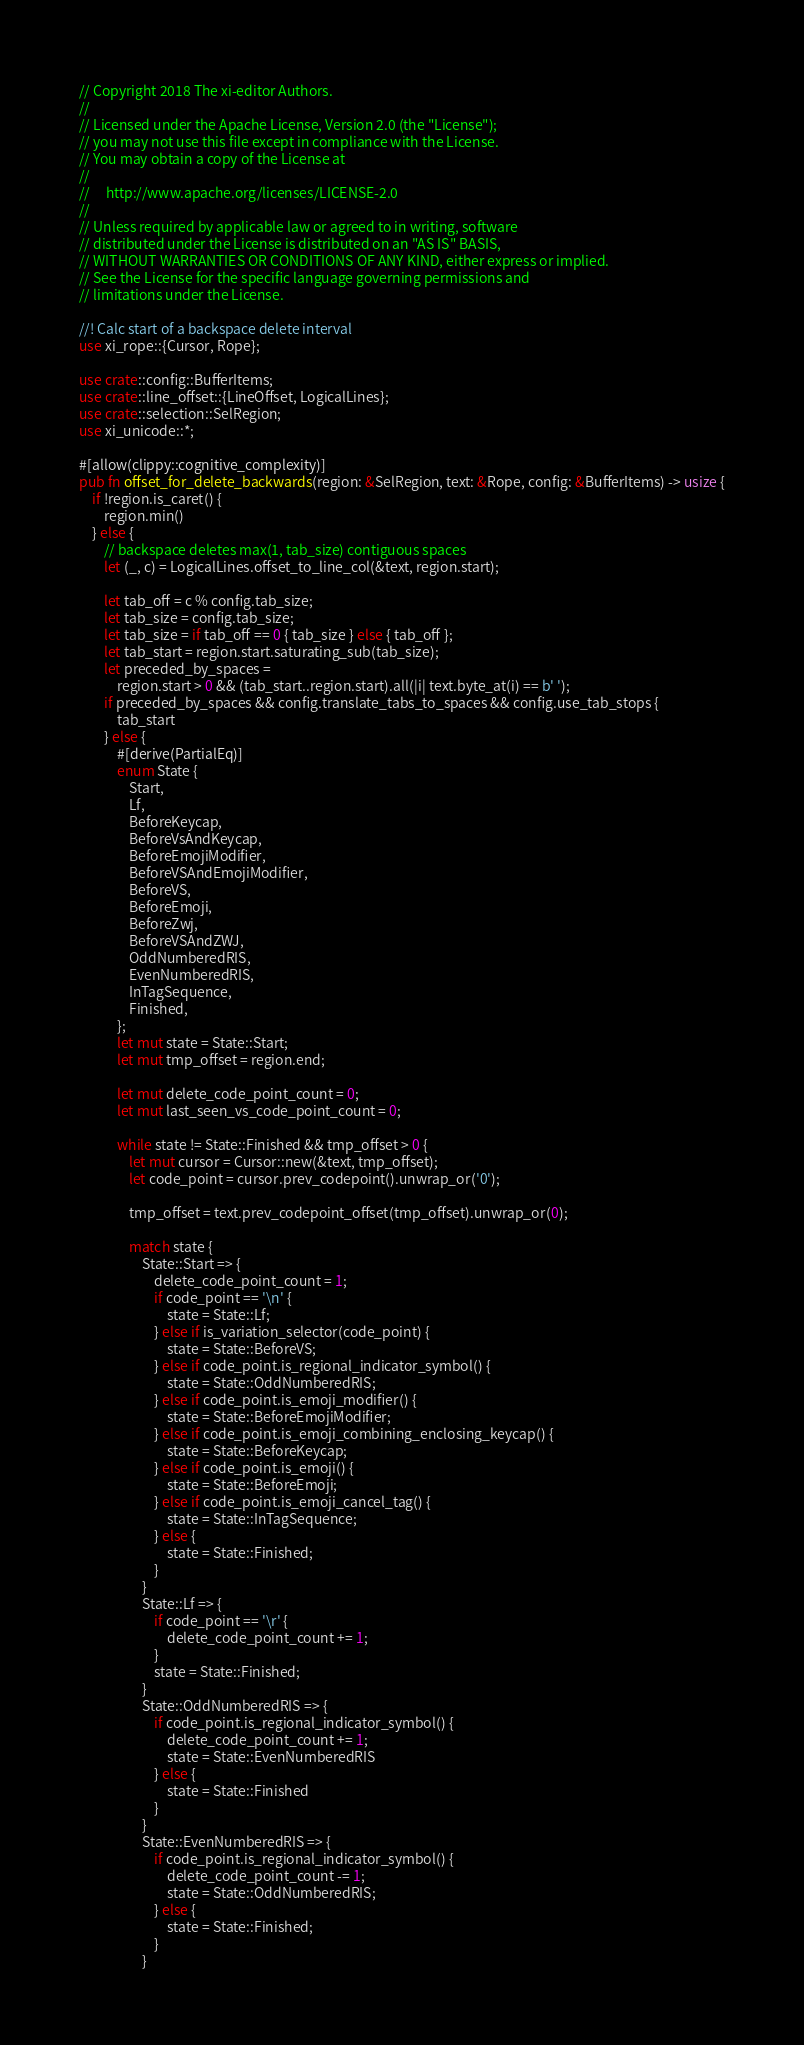<code> <loc_0><loc_0><loc_500><loc_500><_Rust_>// Copyright 2018 The xi-editor Authors.
//
// Licensed under the Apache License, Version 2.0 (the "License");
// you may not use this file except in compliance with the License.
// You may obtain a copy of the License at
//
//     http://www.apache.org/licenses/LICENSE-2.0
//
// Unless required by applicable law or agreed to in writing, software
// distributed under the License is distributed on an "AS IS" BASIS,
// WITHOUT WARRANTIES OR CONDITIONS OF ANY KIND, either express or implied.
// See the License for the specific language governing permissions and
// limitations under the License.

//! Calc start of a backspace delete interval
use xi_rope::{Cursor, Rope};

use crate::config::BufferItems;
use crate::line_offset::{LineOffset, LogicalLines};
use crate::selection::SelRegion;
use xi_unicode::*;

#[allow(clippy::cognitive_complexity)]
pub fn offset_for_delete_backwards(region: &SelRegion, text: &Rope, config: &BufferItems) -> usize {
    if !region.is_caret() {
        region.min()
    } else {
        // backspace deletes max(1, tab_size) contiguous spaces
        let (_, c) = LogicalLines.offset_to_line_col(&text, region.start);

        let tab_off = c % config.tab_size;
        let tab_size = config.tab_size;
        let tab_size = if tab_off == 0 { tab_size } else { tab_off };
        let tab_start = region.start.saturating_sub(tab_size);
        let preceded_by_spaces =
            region.start > 0 && (tab_start..region.start).all(|i| text.byte_at(i) == b' ');
        if preceded_by_spaces && config.translate_tabs_to_spaces && config.use_tab_stops {
            tab_start
        } else {
            #[derive(PartialEq)]
            enum State {
                Start,
                Lf,
                BeforeKeycap,
                BeforeVsAndKeycap,
                BeforeEmojiModifier,
                BeforeVSAndEmojiModifier,
                BeforeVS,
                BeforeEmoji,
                BeforeZwj,
                BeforeVSAndZWJ,
                OddNumberedRIS,
                EvenNumberedRIS,
                InTagSequence,
                Finished,
            };
            let mut state = State::Start;
            let mut tmp_offset = region.end;

            let mut delete_code_point_count = 0;
            let mut last_seen_vs_code_point_count = 0;

            while state != State::Finished && tmp_offset > 0 {
                let mut cursor = Cursor::new(&text, tmp_offset);
                let code_point = cursor.prev_codepoint().unwrap_or('0');

                tmp_offset = text.prev_codepoint_offset(tmp_offset).unwrap_or(0);

                match state {
                    State::Start => {
                        delete_code_point_count = 1;
                        if code_point == '\n' {
                            state = State::Lf;
                        } else if is_variation_selector(code_point) {
                            state = State::BeforeVS;
                        } else if code_point.is_regional_indicator_symbol() {
                            state = State::OddNumberedRIS;
                        } else if code_point.is_emoji_modifier() {
                            state = State::BeforeEmojiModifier;
                        } else if code_point.is_emoji_combining_enclosing_keycap() {
                            state = State::BeforeKeycap;
                        } else if code_point.is_emoji() {
                            state = State::BeforeEmoji;
                        } else if code_point.is_emoji_cancel_tag() {
                            state = State::InTagSequence;
                        } else {
                            state = State::Finished;
                        }
                    }
                    State::Lf => {
                        if code_point == '\r' {
                            delete_code_point_count += 1;
                        }
                        state = State::Finished;
                    }
                    State::OddNumberedRIS => {
                        if code_point.is_regional_indicator_symbol() {
                            delete_code_point_count += 1;
                            state = State::EvenNumberedRIS
                        } else {
                            state = State::Finished
                        }
                    }
                    State::EvenNumberedRIS => {
                        if code_point.is_regional_indicator_symbol() {
                            delete_code_point_count -= 1;
                            state = State::OddNumberedRIS;
                        } else {
                            state = State::Finished;
                        }
                    }</code> 